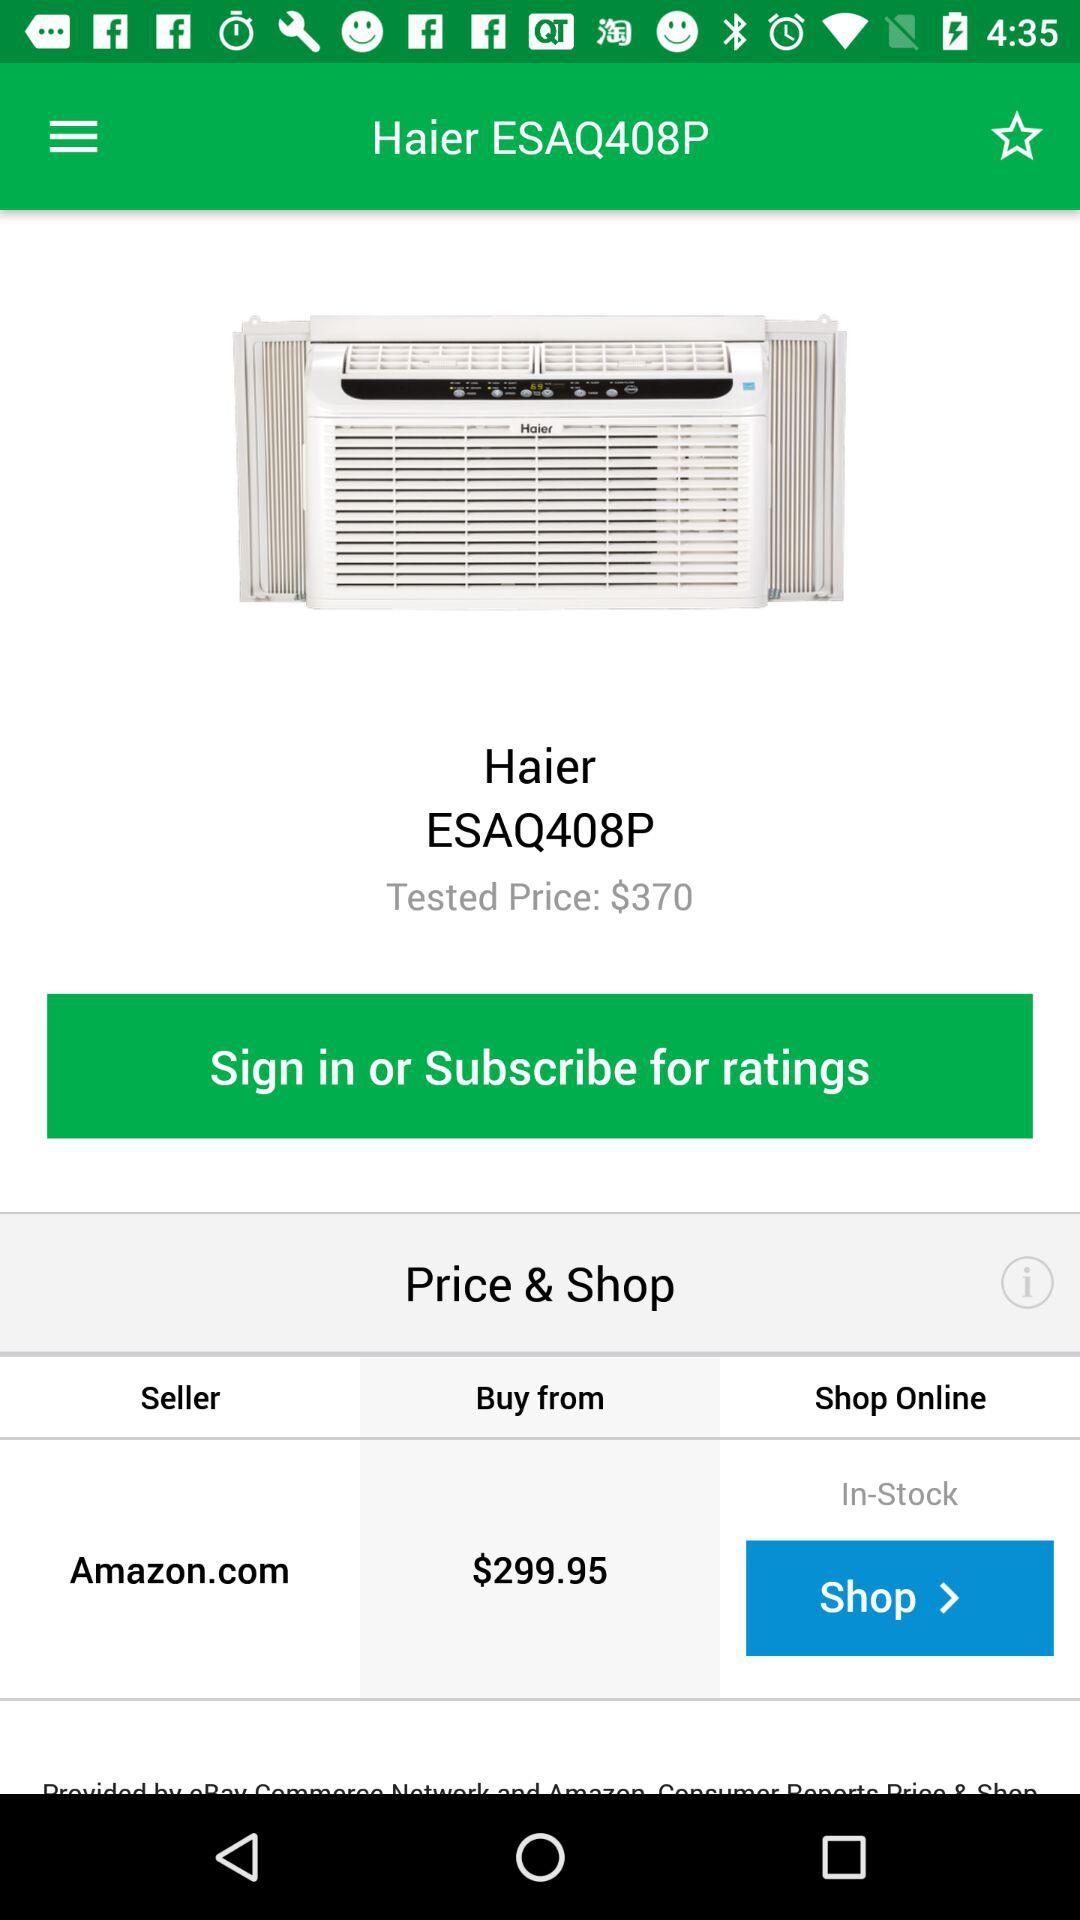What is the seller's site? The seller's site is Amazon.com. 